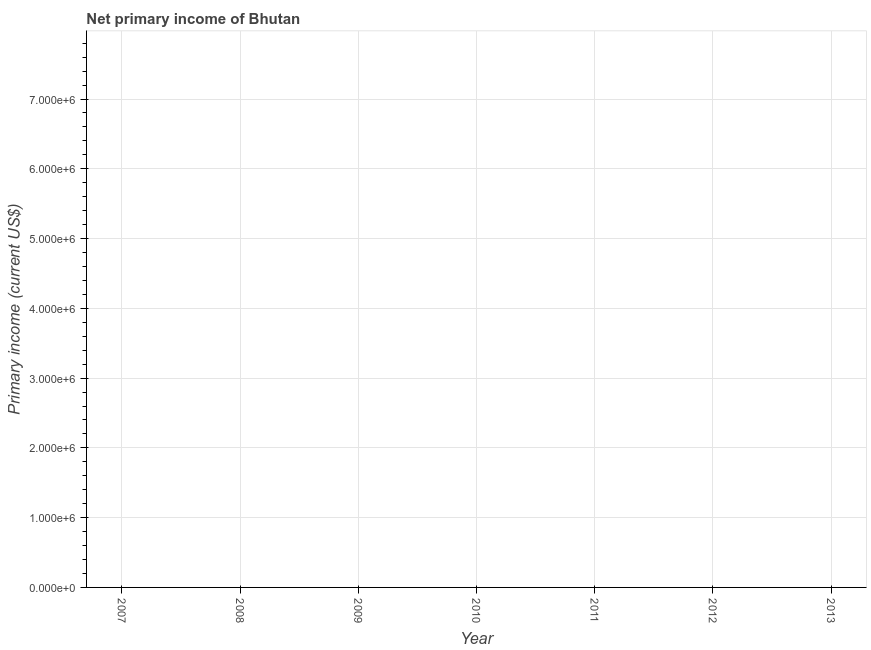What is the amount of primary income in 2009?
Offer a very short reply. 0. What is the median amount of primary income?
Your answer should be very brief. 0. In how many years, is the amount of primary income greater than 1000000 US$?
Provide a succinct answer. 0. How many dotlines are there?
Provide a succinct answer. 0. Are the values on the major ticks of Y-axis written in scientific E-notation?
Provide a short and direct response. Yes. What is the title of the graph?
Offer a very short reply. Net primary income of Bhutan. What is the label or title of the Y-axis?
Make the answer very short. Primary income (current US$). What is the Primary income (current US$) in 2008?
Your answer should be compact. 0. What is the Primary income (current US$) in 2009?
Keep it short and to the point. 0. What is the Primary income (current US$) in 2010?
Your answer should be very brief. 0. What is the Primary income (current US$) in 2012?
Ensure brevity in your answer.  0. What is the Primary income (current US$) in 2013?
Give a very brief answer. 0. 